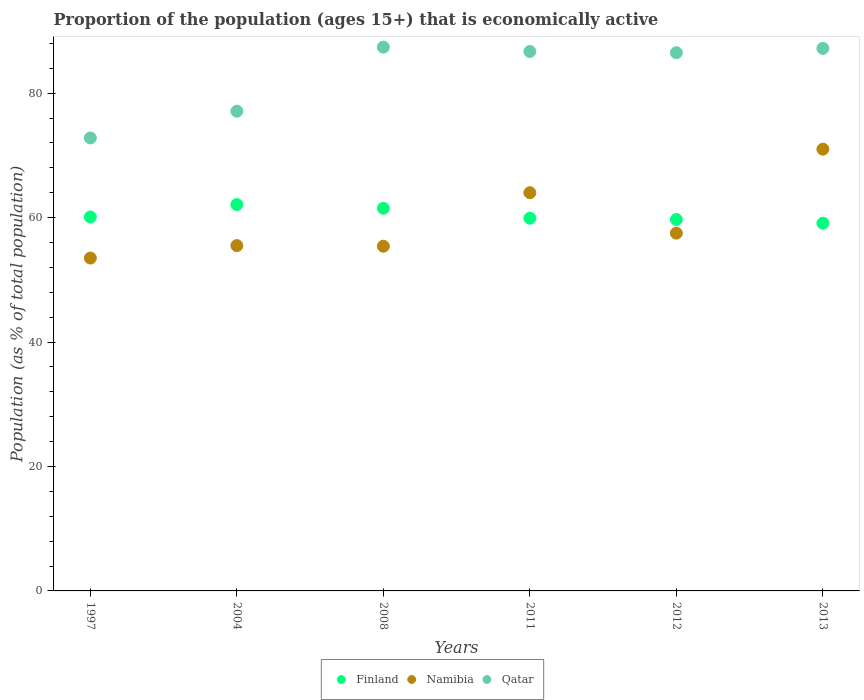How many different coloured dotlines are there?
Make the answer very short. 3. Is the number of dotlines equal to the number of legend labels?
Give a very brief answer. Yes. Across all years, what is the minimum proportion of the population that is economically active in Namibia?
Your response must be concise. 53.5. What is the total proportion of the population that is economically active in Namibia in the graph?
Make the answer very short. 356.9. What is the difference between the proportion of the population that is economically active in Finland in 2012 and that in 2013?
Ensure brevity in your answer.  0.6. What is the difference between the proportion of the population that is economically active in Namibia in 2008 and the proportion of the population that is economically active in Qatar in 2012?
Provide a succinct answer. -31.1. What is the average proportion of the population that is economically active in Finland per year?
Make the answer very short. 60.4. In the year 2012, what is the difference between the proportion of the population that is economically active in Qatar and proportion of the population that is economically active in Namibia?
Your answer should be very brief. 29. In how many years, is the proportion of the population that is economically active in Namibia greater than 60 %?
Make the answer very short. 2. What is the ratio of the proportion of the population that is economically active in Qatar in 1997 to that in 2012?
Ensure brevity in your answer.  0.84. Is the difference between the proportion of the population that is economically active in Qatar in 2004 and 2012 greater than the difference between the proportion of the population that is economically active in Namibia in 2004 and 2012?
Keep it short and to the point. No. What is the difference between the highest and the lowest proportion of the population that is economically active in Namibia?
Provide a succinct answer. 17.5. Does the proportion of the population that is economically active in Namibia monotonically increase over the years?
Offer a terse response. No. Is the proportion of the population that is economically active in Finland strictly greater than the proportion of the population that is economically active in Namibia over the years?
Make the answer very short. No. What is the difference between two consecutive major ticks on the Y-axis?
Give a very brief answer. 20. Does the graph contain any zero values?
Give a very brief answer. No. Where does the legend appear in the graph?
Give a very brief answer. Bottom center. What is the title of the graph?
Make the answer very short. Proportion of the population (ages 15+) that is economically active. Does "Turkmenistan" appear as one of the legend labels in the graph?
Your answer should be very brief. No. What is the label or title of the X-axis?
Provide a succinct answer. Years. What is the label or title of the Y-axis?
Give a very brief answer. Population (as % of total population). What is the Population (as % of total population) of Finland in 1997?
Provide a short and direct response. 60.1. What is the Population (as % of total population) of Namibia in 1997?
Keep it short and to the point. 53.5. What is the Population (as % of total population) in Qatar in 1997?
Your answer should be compact. 72.8. What is the Population (as % of total population) in Finland in 2004?
Ensure brevity in your answer.  62.1. What is the Population (as % of total population) in Namibia in 2004?
Your answer should be very brief. 55.5. What is the Population (as % of total population) of Qatar in 2004?
Ensure brevity in your answer.  77.1. What is the Population (as % of total population) of Finland in 2008?
Give a very brief answer. 61.5. What is the Population (as % of total population) in Namibia in 2008?
Your answer should be very brief. 55.4. What is the Population (as % of total population) in Qatar in 2008?
Give a very brief answer. 87.4. What is the Population (as % of total population) of Finland in 2011?
Give a very brief answer. 59.9. What is the Population (as % of total population) in Qatar in 2011?
Your answer should be very brief. 86.7. What is the Population (as % of total population) in Finland in 2012?
Offer a terse response. 59.7. What is the Population (as % of total population) in Namibia in 2012?
Provide a short and direct response. 57.5. What is the Population (as % of total population) in Qatar in 2012?
Offer a terse response. 86.5. What is the Population (as % of total population) of Finland in 2013?
Offer a very short reply. 59.1. What is the Population (as % of total population) in Namibia in 2013?
Offer a very short reply. 71. What is the Population (as % of total population) of Qatar in 2013?
Your answer should be very brief. 87.2. Across all years, what is the maximum Population (as % of total population) of Finland?
Give a very brief answer. 62.1. Across all years, what is the maximum Population (as % of total population) of Qatar?
Ensure brevity in your answer.  87.4. Across all years, what is the minimum Population (as % of total population) in Finland?
Ensure brevity in your answer.  59.1. Across all years, what is the minimum Population (as % of total population) of Namibia?
Your answer should be very brief. 53.5. Across all years, what is the minimum Population (as % of total population) in Qatar?
Provide a short and direct response. 72.8. What is the total Population (as % of total population) of Finland in the graph?
Your answer should be very brief. 362.4. What is the total Population (as % of total population) of Namibia in the graph?
Make the answer very short. 356.9. What is the total Population (as % of total population) of Qatar in the graph?
Offer a very short reply. 497.7. What is the difference between the Population (as % of total population) of Finland in 1997 and that in 2004?
Give a very brief answer. -2. What is the difference between the Population (as % of total population) in Namibia in 1997 and that in 2004?
Your answer should be compact. -2. What is the difference between the Population (as % of total population) in Qatar in 1997 and that in 2004?
Provide a short and direct response. -4.3. What is the difference between the Population (as % of total population) of Namibia in 1997 and that in 2008?
Your response must be concise. -1.9. What is the difference between the Population (as % of total population) in Qatar in 1997 and that in 2008?
Provide a short and direct response. -14.6. What is the difference between the Population (as % of total population) in Namibia in 1997 and that in 2011?
Your answer should be compact. -10.5. What is the difference between the Population (as % of total population) in Finland in 1997 and that in 2012?
Give a very brief answer. 0.4. What is the difference between the Population (as % of total population) of Qatar in 1997 and that in 2012?
Give a very brief answer. -13.7. What is the difference between the Population (as % of total population) in Finland in 1997 and that in 2013?
Give a very brief answer. 1. What is the difference between the Population (as % of total population) of Namibia in 1997 and that in 2013?
Ensure brevity in your answer.  -17.5. What is the difference between the Population (as % of total population) in Qatar in 1997 and that in 2013?
Provide a short and direct response. -14.4. What is the difference between the Population (as % of total population) of Finland in 2004 and that in 2008?
Offer a terse response. 0.6. What is the difference between the Population (as % of total population) in Namibia in 2004 and that in 2008?
Keep it short and to the point. 0.1. What is the difference between the Population (as % of total population) of Qatar in 2004 and that in 2008?
Provide a short and direct response. -10.3. What is the difference between the Population (as % of total population) in Finland in 2004 and that in 2011?
Your answer should be very brief. 2.2. What is the difference between the Population (as % of total population) in Qatar in 2004 and that in 2011?
Ensure brevity in your answer.  -9.6. What is the difference between the Population (as % of total population) of Namibia in 2004 and that in 2013?
Offer a terse response. -15.5. What is the difference between the Population (as % of total population) of Qatar in 2004 and that in 2013?
Provide a succinct answer. -10.1. What is the difference between the Population (as % of total population) of Finland in 2008 and that in 2013?
Ensure brevity in your answer.  2.4. What is the difference between the Population (as % of total population) in Namibia in 2008 and that in 2013?
Give a very brief answer. -15.6. What is the difference between the Population (as % of total population) in Qatar in 2008 and that in 2013?
Ensure brevity in your answer.  0.2. What is the difference between the Population (as % of total population) in Namibia in 2011 and that in 2012?
Your answer should be compact. 6.5. What is the difference between the Population (as % of total population) of Qatar in 2011 and that in 2012?
Keep it short and to the point. 0.2. What is the difference between the Population (as % of total population) in Namibia in 2011 and that in 2013?
Offer a very short reply. -7. What is the difference between the Population (as % of total population) in Qatar in 2011 and that in 2013?
Make the answer very short. -0.5. What is the difference between the Population (as % of total population) of Finland in 2012 and that in 2013?
Ensure brevity in your answer.  0.6. What is the difference between the Population (as % of total population) of Finland in 1997 and the Population (as % of total population) of Namibia in 2004?
Provide a short and direct response. 4.6. What is the difference between the Population (as % of total population) in Namibia in 1997 and the Population (as % of total population) in Qatar in 2004?
Your answer should be compact. -23.6. What is the difference between the Population (as % of total population) of Finland in 1997 and the Population (as % of total population) of Namibia in 2008?
Keep it short and to the point. 4.7. What is the difference between the Population (as % of total population) of Finland in 1997 and the Population (as % of total population) of Qatar in 2008?
Give a very brief answer. -27.3. What is the difference between the Population (as % of total population) of Namibia in 1997 and the Population (as % of total population) of Qatar in 2008?
Provide a short and direct response. -33.9. What is the difference between the Population (as % of total population) in Finland in 1997 and the Population (as % of total population) in Qatar in 2011?
Give a very brief answer. -26.6. What is the difference between the Population (as % of total population) in Namibia in 1997 and the Population (as % of total population) in Qatar in 2011?
Give a very brief answer. -33.2. What is the difference between the Population (as % of total population) in Finland in 1997 and the Population (as % of total population) in Namibia in 2012?
Provide a succinct answer. 2.6. What is the difference between the Population (as % of total population) in Finland in 1997 and the Population (as % of total population) in Qatar in 2012?
Keep it short and to the point. -26.4. What is the difference between the Population (as % of total population) of Namibia in 1997 and the Population (as % of total population) of Qatar in 2012?
Keep it short and to the point. -33. What is the difference between the Population (as % of total population) of Finland in 1997 and the Population (as % of total population) of Namibia in 2013?
Offer a terse response. -10.9. What is the difference between the Population (as % of total population) in Finland in 1997 and the Population (as % of total population) in Qatar in 2013?
Provide a short and direct response. -27.1. What is the difference between the Population (as % of total population) in Namibia in 1997 and the Population (as % of total population) in Qatar in 2013?
Provide a succinct answer. -33.7. What is the difference between the Population (as % of total population) in Finland in 2004 and the Population (as % of total population) in Qatar in 2008?
Offer a terse response. -25.3. What is the difference between the Population (as % of total population) of Namibia in 2004 and the Population (as % of total population) of Qatar in 2008?
Make the answer very short. -31.9. What is the difference between the Population (as % of total population) of Finland in 2004 and the Population (as % of total population) of Namibia in 2011?
Make the answer very short. -1.9. What is the difference between the Population (as % of total population) of Finland in 2004 and the Population (as % of total population) of Qatar in 2011?
Provide a succinct answer. -24.6. What is the difference between the Population (as % of total population) in Namibia in 2004 and the Population (as % of total population) in Qatar in 2011?
Keep it short and to the point. -31.2. What is the difference between the Population (as % of total population) of Finland in 2004 and the Population (as % of total population) of Qatar in 2012?
Offer a terse response. -24.4. What is the difference between the Population (as % of total population) in Namibia in 2004 and the Population (as % of total population) in Qatar in 2012?
Ensure brevity in your answer.  -31. What is the difference between the Population (as % of total population) in Finland in 2004 and the Population (as % of total population) in Qatar in 2013?
Offer a terse response. -25.1. What is the difference between the Population (as % of total population) in Namibia in 2004 and the Population (as % of total population) in Qatar in 2013?
Keep it short and to the point. -31.7. What is the difference between the Population (as % of total population) in Finland in 2008 and the Population (as % of total population) in Namibia in 2011?
Ensure brevity in your answer.  -2.5. What is the difference between the Population (as % of total population) of Finland in 2008 and the Population (as % of total population) of Qatar in 2011?
Make the answer very short. -25.2. What is the difference between the Population (as % of total population) in Namibia in 2008 and the Population (as % of total population) in Qatar in 2011?
Offer a very short reply. -31.3. What is the difference between the Population (as % of total population) in Namibia in 2008 and the Population (as % of total population) in Qatar in 2012?
Your response must be concise. -31.1. What is the difference between the Population (as % of total population) of Finland in 2008 and the Population (as % of total population) of Namibia in 2013?
Offer a terse response. -9.5. What is the difference between the Population (as % of total population) in Finland in 2008 and the Population (as % of total population) in Qatar in 2013?
Provide a succinct answer. -25.7. What is the difference between the Population (as % of total population) in Namibia in 2008 and the Population (as % of total population) in Qatar in 2013?
Ensure brevity in your answer.  -31.8. What is the difference between the Population (as % of total population) in Finland in 2011 and the Population (as % of total population) in Namibia in 2012?
Keep it short and to the point. 2.4. What is the difference between the Population (as % of total population) of Finland in 2011 and the Population (as % of total population) of Qatar in 2012?
Your answer should be very brief. -26.6. What is the difference between the Population (as % of total population) of Namibia in 2011 and the Population (as % of total population) of Qatar in 2012?
Your answer should be very brief. -22.5. What is the difference between the Population (as % of total population) of Finland in 2011 and the Population (as % of total population) of Namibia in 2013?
Provide a short and direct response. -11.1. What is the difference between the Population (as % of total population) in Finland in 2011 and the Population (as % of total population) in Qatar in 2013?
Ensure brevity in your answer.  -27.3. What is the difference between the Population (as % of total population) in Namibia in 2011 and the Population (as % of total population) in Qatar in 2013?
Provide a short and direct response. -23.2. What is the difference between the Population (as % of total population) in Finland in 2012 and the Population (as % of total population) in Qatar in 2013?
Provide a succinct answer. -27.5. What is the difference between the Population (as % of total population) in Namibia in 2012 and the Population (as % of total population) in Qatar in 2013?
Keep it short and to the point. -29.7. What is the average Population (as % of total population) in Finland per year?
Offer a terse response. 60.4. What is the average Population (as % of total population) in Namibia per year?
Keep it short and to the point. 59.48. What is the average Population (as % of total population) of Qatar per year?
Your answer should be very brief. 82.95. In the year 1997, what is the difference between the Population (as % of total population) in Namibia and Population (as % of total population) in Qatar?
Give a very brief answer. -19.3. In the year 2004, what is the difference between the Population (as % of total population) in Finland and Population (as % of total population) in Namibia?
Offer a very short reply. 6.6. In the year 2004, what is the difference between the Population (as % of total population) of Namibia and Population (as % of total population) of Qatar?
Your answer should be very brief. -21.6. In the year 2008, what is the difference between the Population (as % of total population) of Finland and Population (as % of total population) of Namibia?
Provide a succinct answer. 6.1. In the year 2008, what is the difference between the Population (as % of total population) in Finland and Population (as % of total population) in Qatar?
Provide a short and direct response. -25.9. In the year 2008, what is the difference between the Population (as % of total population) in Namibia and Population (as % of total population) in Qatar?
Offer a very short reply. -32. In the year 2011, what is the difference between the Population (as % of total population) in Finland and Population (as % of total population) in Namibia?
Give a very brief answer. -4.1. In the year 2011, what is the difference between the Population (as % of total population) of Finland and Population (as % of total population) of Qatar?
Provide a succinct answer. -26.8. In the year 2011, what is the difference between the Population (as % of total population) of Namibia and Population (as % of total population) of Qatar?
Give a very brief answer. -22.7. In the year 2012, what is the difference between the Population (as % of total population) of Finland and Population (as % of total population) of Qatar?
Offer a terse response. -26.8. In the year 2012, what is the difference between the Population (as % of total population) in Namibia and Population (as % of total population) in Qatar?
Your answer should be very brief. -29. In the year 2013, what is the difference between the Population (as % of total population) in Finland and Population (as % of total population) in Qatar?
Your answer should be very brief. -28.1. In the year 2013, what is the difference between the Population (as % of total population) of Namibia and Population (as % of total population) of Qatar?
Your response must be concise. -16.2. What is the ratio of the Population (as % of total population) in Finland in 1997 to that in 2004?
Ensure brevity in your answer.  0.97. What is the ratio of the Population (as % of total population) in Qatar in 1997 to that in 2004?
Offer a terse response. 0.94. What is the ratio of the Population (as % of total population) in Finland in 1997 to that in 2008?
Offer a terse response. 0.98. What is the ratio of the Population (as % of total population) of Namibia in 1997 to that in 2008?
Your answer should be compact. 0.97. What is the ratio of the Population (as % of total population) of Qatar in 1997 to that in 2008?
Provide a short and direct response. 0.83. What is the ratio of the Population (as % of total population) of Namibia in 1997 to that in 2011?
Your response must be concise. 0.84. What is the ratio of the Population (as % of total population) in Qatar in 1997 to that in 2011?
Give a very brief answer. 0.84. What is the ratio of the Population (as % of total population) of Finland in 1997 to that in 2012?
Keep it short and to the point. 1.01. What is the ratio of the Population (as % of total population) of Namibia in 1997 to that in 2012?
Your response must be concise. 0.93. What is the ratio of the Population (as % of total population) of Qatar in 1997 to that in 2012?
Keep it short and to the point. 0.84. What is the ratio of the Population (as % of total population) in Finland in 1997 to that in 2013?
Give a very brief answer. 1.02. What is the ratio of the Population (as % of total population) of Namibia in 1997 to that in 2013?
Keep it short and to the point. 0.75. What is the ratio of the Population (as % of total population) in Qatar in 1997 to that in 2013?
Offer a terse response. 0.83. What is the ratio of the Population (as % of total population) in Finland in 2004 to that in 2008?
Offer a terse response. 1.01. What is the ratio of the Population (as % of total population) in Namibia in 2004 to that in 2008?
Provide a succinct answer. 1. What is the ratio of the Population (as % of total population) in Qatar in 2004 to that in 2008?
Your answer should be compact. 0.88. What is the ratio of the Population (as % of total population) of Finland in 2004 to that in 2011?
Provide a succinct answer. 1.04. What is the ratio of the Population (as % of total population) of Namibia in 2004 to that in 2011?
Make the answer very short. 0.87. What is the ratio of the Population (as % of total population) in Qatar in 2004 to that in 2011?
Your answer should be very brief. 0.89. What is the ratio of the Population (as % of total population) of Finland in 2004 to that in 2012?
Your answer should be very brief. 1.04. What is the ratio of the Population (as % of total population) in Namibia in 2004 to that in 2012?
Offer a very short reply. 0.97. What is the ratio of the Population (as % of total population) in Qatar in 2004 to that in 2012?
Offer a terse response. 0.89. What is the ratio of the Population (as % of total population) in Finland in 2004 to that in 2013?
Keep it short and to the point. 1.05. What is the ratio of the Population (as % of total population) in Namibia in 2004 to that in 2013?
Offer a very short reply. 0.78. What is the ratio of the Population (as % of total population) in Qatar in 2004 to that in 2013?
Offer a terse response. 0.88. What is the ratio of the Population (as % of total population) in Finland in 2008 to that in 2011?
Provide a short and direct response. 1.03. What is the ratio of the Population (as % of total population) of Namibia in 2008 to that in 2011?
Your response must be concise. 0.87. What is the ratio of the Population (as % of total population) of Qatar in 2008 to that in 2011?
Ensure brevity in your answer.  1.01. What is the ratio of the Population (as % of total population) in Finland in 2008 to that in 2012?
Your response must be concise. 1.03. What is the ratio of the Population (as % of total population) in Namibia in 2008 to that in 2012?
Offer a very short reply. 0.96. What is the ratio of the Population (as % of total population) of Qatar in 2008 to that in 2012?
Keep it short and to the point. 1.01. What is the ratio of the Population (as % of total population) of Finland in 2008 to that in 2013?
Make the answer very short. 1.04. What is the ratio of the Population (as % of total population) of Namibia in 2008 to that in 2013?
Offer a terse response. 0.78. What is the ratio of the Population (as % of total population) in Finland in 2011 to that in 2012?
Your response must be concise. 1. What is the ratio of the Population (as % of total population) of Namibia in 2011 to that in 2012?
Ensure brevity in your answer.  1.11. What is the ratio of the Population (as % of total population) of Qatar in 2011 to that in 2012?
Provide a short and direct response. 1. What is the ratio of the Population (as % of total population) in Finland in 2011 to that in 2013?
Your answer should be compact. 1.01. What is the ratio of the Population (as % of total population) in Namibia in 2011 to that in 2013?
Your answer should be very brief. 0.9. What is the ratio of the Population (as % of total population) of Qatar in 2011 to that in 2013?
Your response must be concise. 0.99. What is the ratio of the Population (as % of total population) in Finland in 2012 to that in 2013?
Provide a succinct answer. 1.01. What is the ratio of the Population (as % of total population) in Namibia in 2012 to that in 2013?
Offer a very short reply. 0.81. What is the difference between the highest and the second highest Population (as % of total population) in Finland?
Give a very brief answer. 0.6. What is the difference between the highest and the second highest Population (as % of total population) in Qatar?
Provide a succinct answer. 0.2. What is the difference between the highest and the lowest Population (as % of total population) of Finland?
Provide a short and direct response. 3. What is the difference between the highest and the lowest Population (as % of total population) in Qatar?
Make the answer very short. 14.6. 